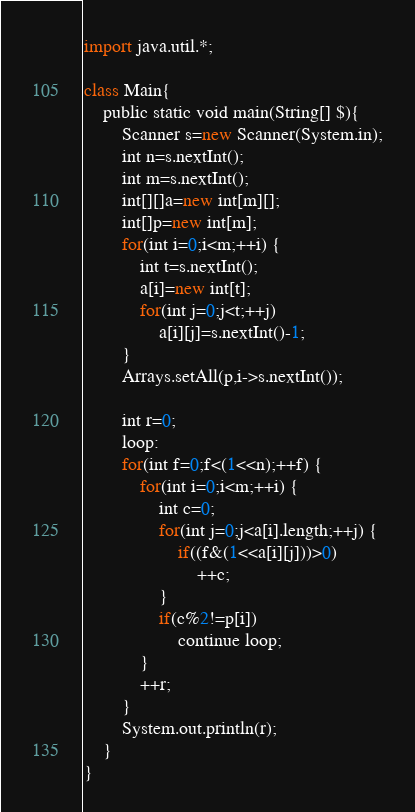<code> <loc_0><loc_0><loc_500><loc_500><_Scala_>import java.util.*;

class Main{
	public static void main(String[] $){
		Scanner s=new Scanner(System.in);
		int n=s.nextInt();
		int m=s.nextInt();
		int[][]a=new int[m][];
		int[]p=new int[m];
		for(int i=0;i<m;++i) {
			int t=s.nextInt();
			a[i]=new int[t];
			for(int j=0;j<t;++j)
				a[i][j]=s.nextInt()-1;
		}
		Arrays.setAll(p,i->s.nextInt());

		int r=0;
		loop:
		for(int f=0;f<(1<<n);++f) {
			for(int i=0;i<m;++i) {
				int c=0;
				for(int j=0;j<a[i].length;++j) {
					if((f&(1<<a[i][j]))>0)
						++c;
				}
				if(c%2!=p[i])
					continue loop;
			}
			++r;
		}
		System.out.println(r);
	}
}</code> 